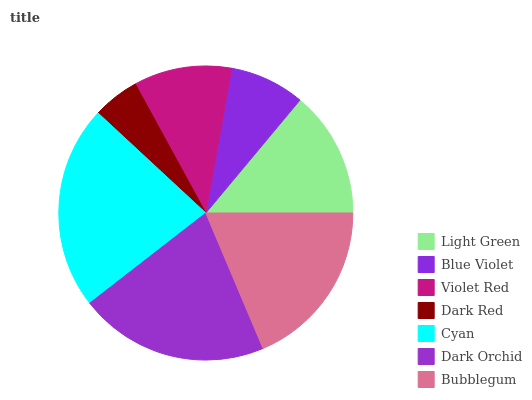Is Dark Red the minimum?
Answer yes or no. Yes. Is Cyan the maximum?
Answer yes or no. Yes. Is Blue Violet the minimum?
Answer yes or no. No. Is Blue Violet the maximum?
Answer yes or no. No. Is Light Green greater than Blue Violet?
Answer yes or no. Yes. Is Blue Violet less than Light Green?
Answer yes or no. Yes. Is Blue Violet greater than Light Green?
Answer yes or no. No. Is Light Green less than Blue Violet?
Answer yes or no. No. Is Light Green the high median?
Answer yes or no. Yes. Is Light Green the low median?
Answer yes or no. Yes. Is Dark Red the high median?
Answer yes or no. No. Is Blue Violet the low median?
Answer yes or no. No. 